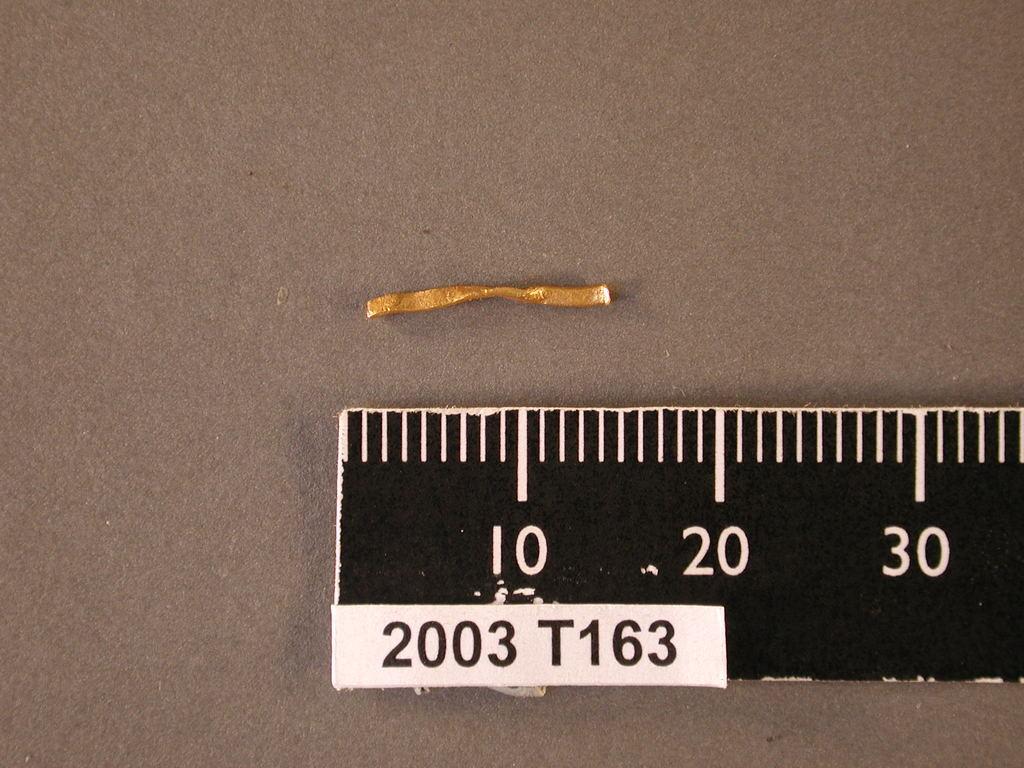How long is the twig?
Ensure brevity in your answer.  15. 